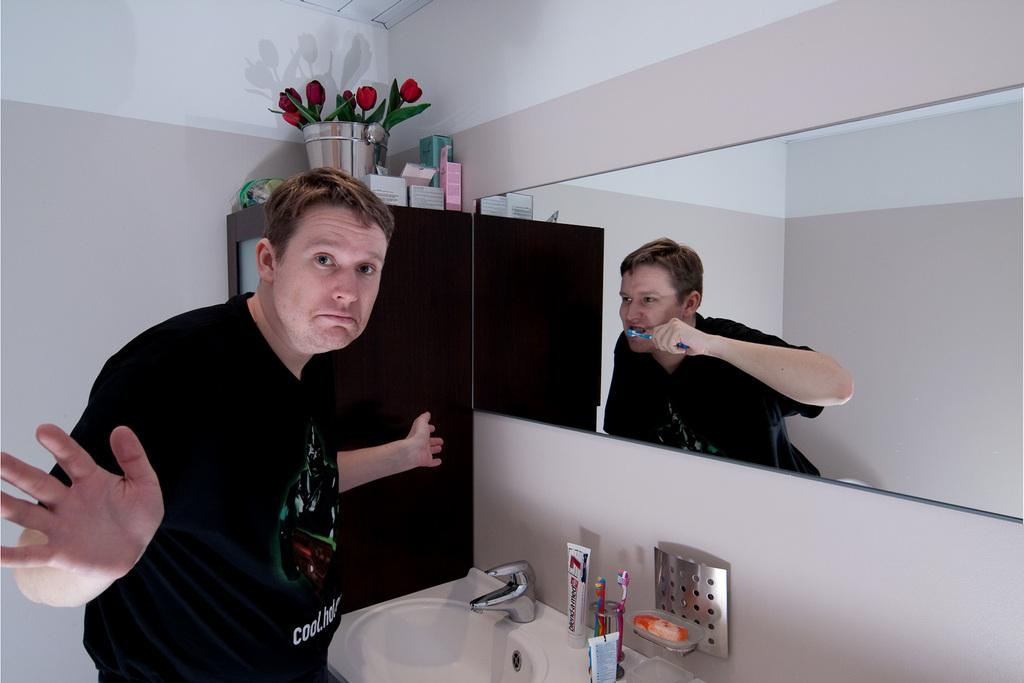<image>
Describe the image concisely. A man in a shirt with the word cool on it stands in front of a bathroom mirror. 